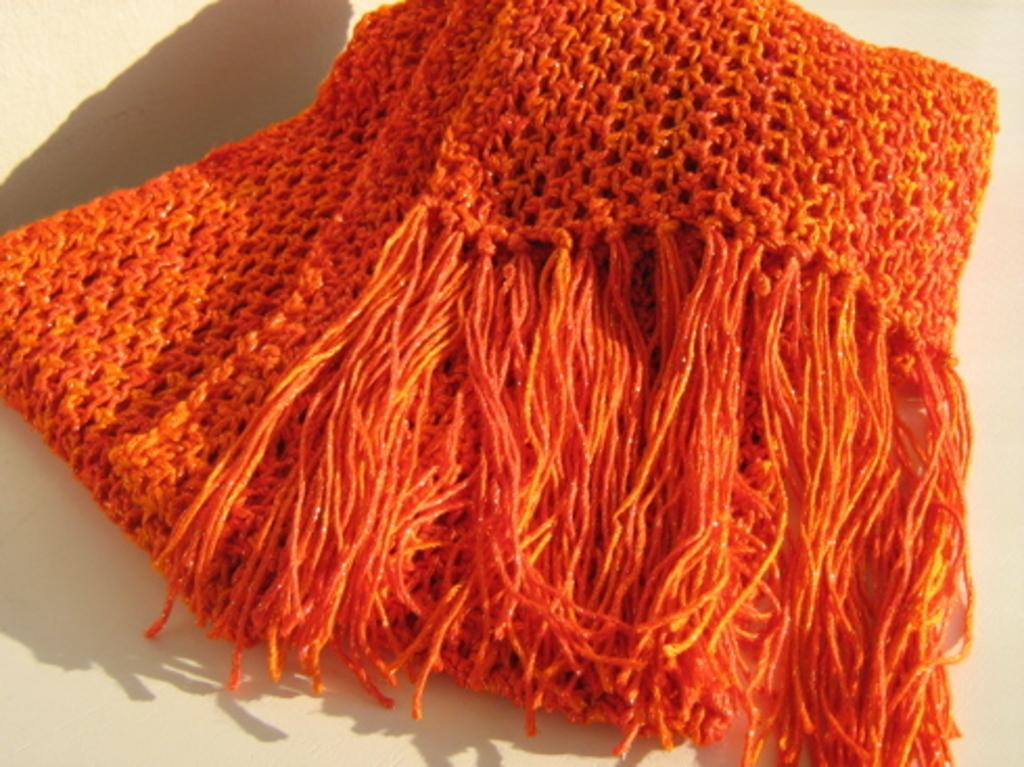What type of garment is present in the image? There is a woolen stole in the image. Where is the woolen stole located? The woolen stole is on the floor. Is there a faucet attached to the woolen stole in the image? No, there is no faucet present in the image, and the woolen stole is not attached to any faucet. 